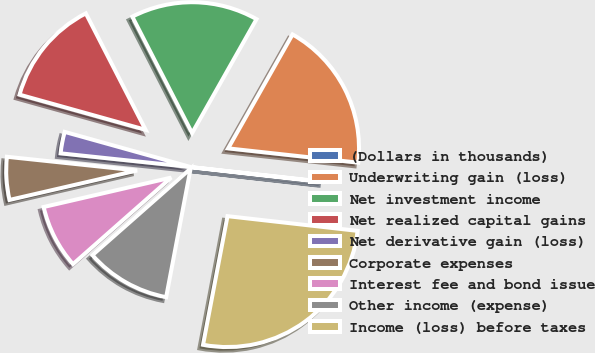Convert chart to OTSL. <chart><loc_0><loc_0><loc_500><loc_500><pie_chart><fcel>(Dollars in thousands)<fcel>Underwriting gain (loss)<fcel>Net investment income<fcel>Net realized capital gains<fcel>Net derivative gain (loss)<fcel>Corporate expenses<fcel>Interest fee and bond issue<fcel>Other income (expense)<fcel>Income (loss) before taxes<nl><fcel>0.05%<fcel>18.55%<fcel>15.74%<fcel>13.12%<fcel>2.66%<fcel>5.28%<fcel>7.89%<fcel>10.51%<fcel>26.2%<nl></chart> 